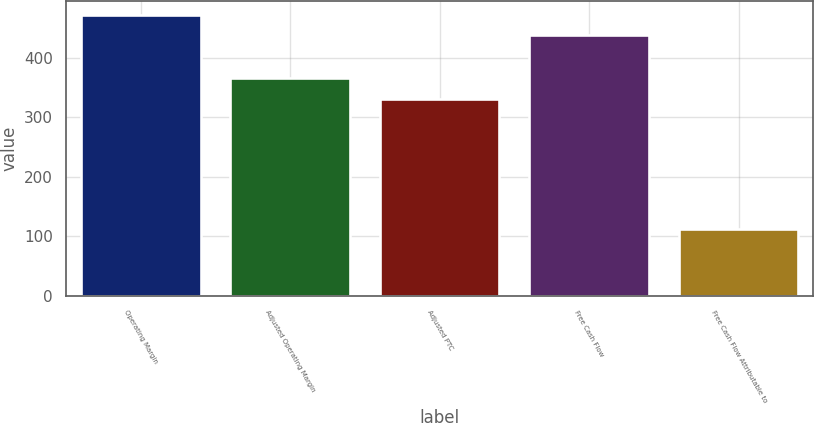<chart> <loc_0><loc_0><loc_500><loc_500><bar_chart><fcel>Operating Margin<fcel>Adjusted Operating Margin<fcel>Adjusted PTC<fcel>Free Cash Flow<fcel>Free Cash Flow Attributable to<nl><fcel>471<fcel>365<fcel>331<fcel>437<fcel>112<nl></chart> 